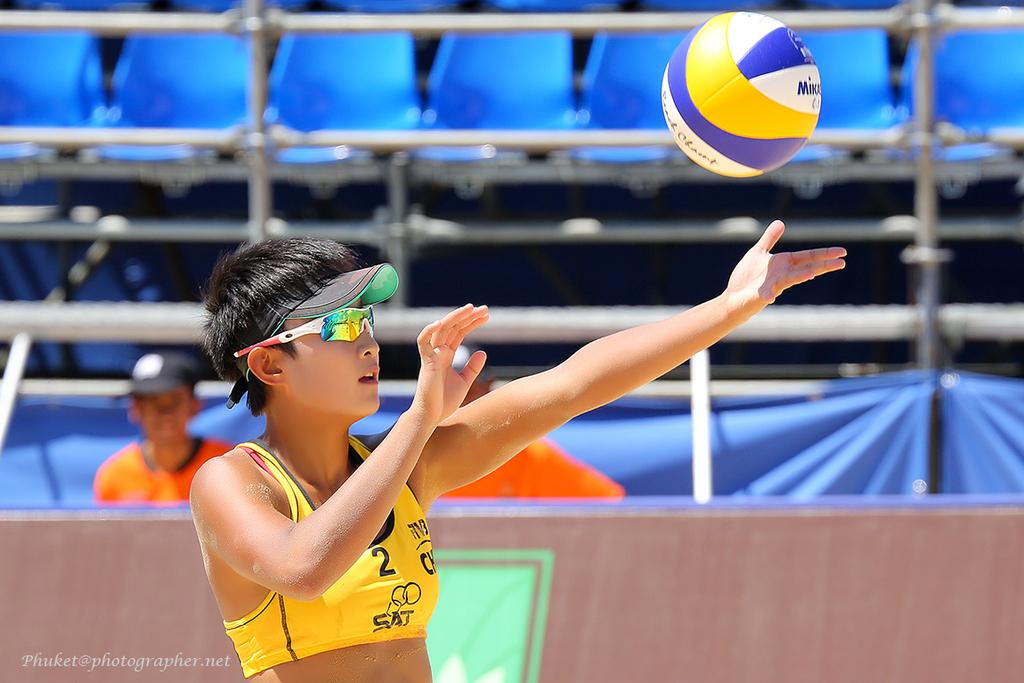<image>
Present a compact description of the photo's key features. A volleyball player with the number 2 on her top 